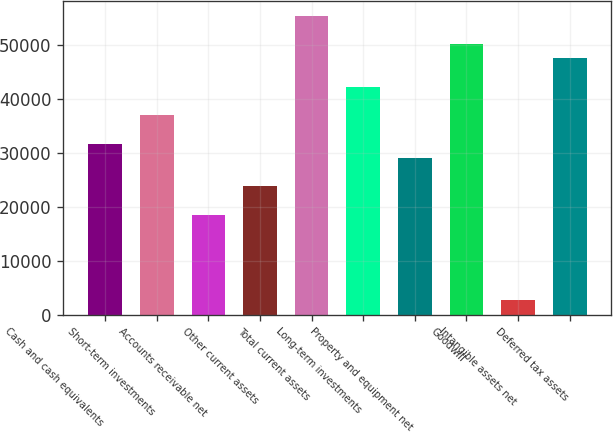Convert chart. <chart><loc_0><loc_0><loc_500><loc_500><bar_chart><fcel>Cash and cash equivalents<fcel>Short-term investments<fcel>Accounts receivable net<fcel>Other current assets<fcel>Total current assets<fcel>Long-term investments<fcel>Property and equipment net<fcel>Goodwill<fcel>Intangible assets net<fcel>Deferred tax assets<nl><fcel>31672.4<fcel>36950.8<fcel>18476.4<fcel>23754.8<fcel>55425.2<fcel>42229.2<fcel>29033.2<fcel>50146.8<fcel>2641.2<fcel>47507.6<nl></chart> 